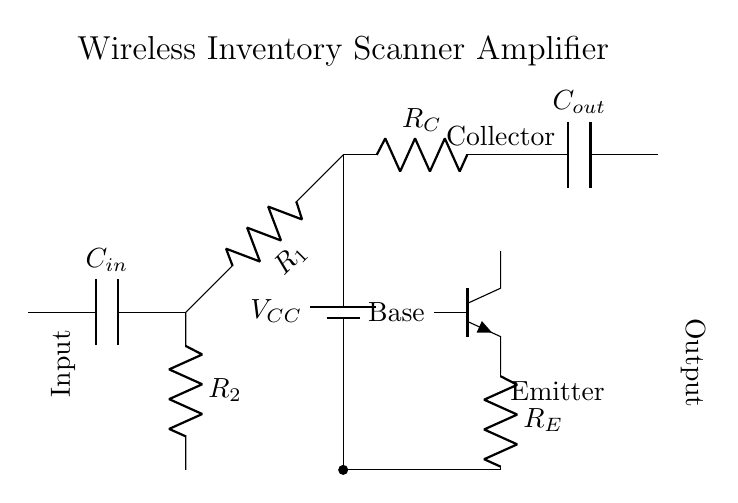What type of transistor is used in this circuit? The circuit uses an NPN transistor, which is indicated by the symbol npn in the diagram.
Answer: NPN What is the purpose of the coupling capacitors? The coupling capacitors, C_in and C_out, allow AC signals to pass while blocking DC components to ensure the transistor receives the correct signal without biasing issues.
Answer: To block DC What is the role of resistor R_C? Resistor R_C is the collector resistor that helps in setting the current flowing through the transistor and contributes to the overall gain of the amplifier circuit.
Answer: Current limiting How many resistors are used for biasing in the base of the transistor? There are two resistors, R_1 and R_2, used for base biasing to establish the operating point of the transistor for amplifying signals.
Answer: Two What is the voltage supply represented in the circuit? The voltage supply is denoted by V_CC, which provides the necessary voltage for the circuit to operate and is connected to the collector resistor.
Answer: V_CC What happens if resistor R_E is increased in value? Increasing R_E (emitter resistor) would decrease the overall gain of the amplifier and stabilize the quiescent point, making the circuit less sensitive to variations in transistor parameters.
Answer: Decreased gain 